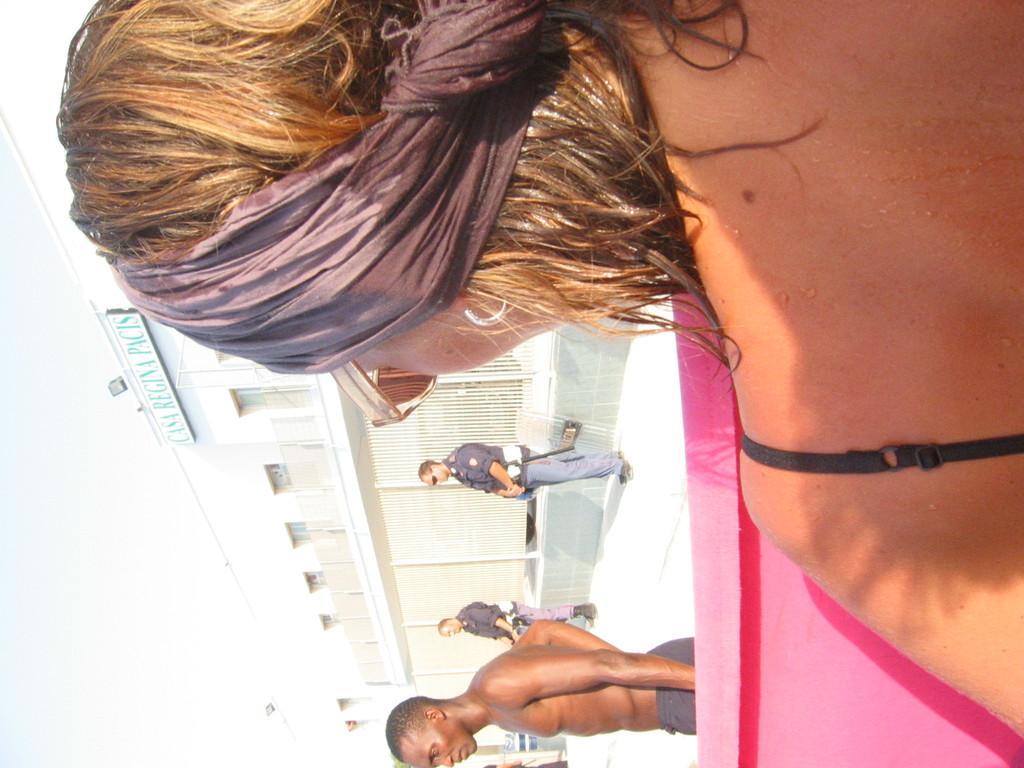Can you describe this image briefly? In this image we can see persons on the floor. In the background we can see building, name board and sky. 